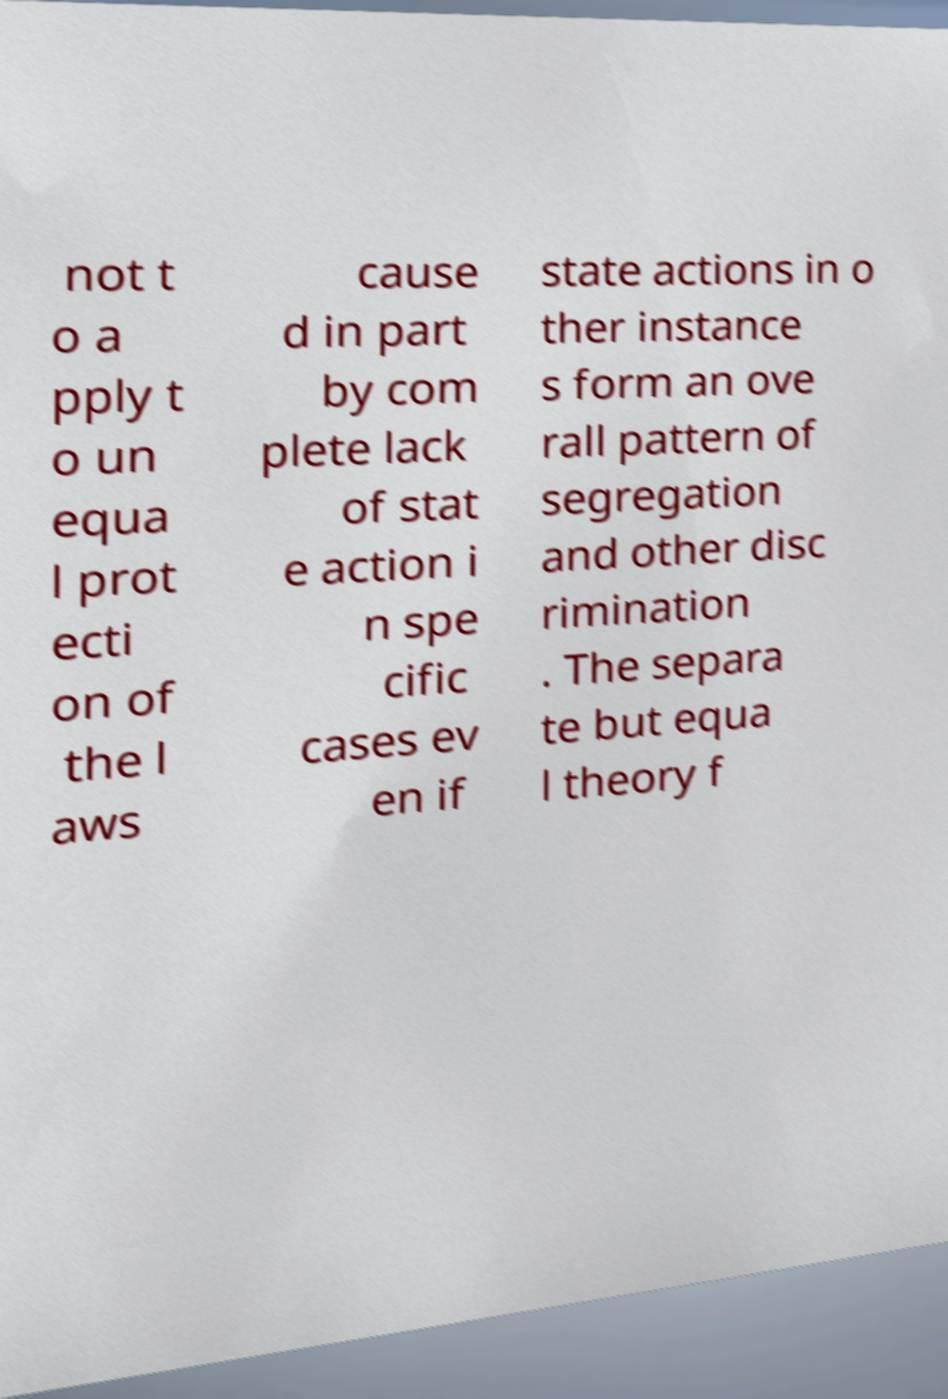For documentation purposes, I need the text within this image transcribed. Could you provide that? not t o a pply t o un equa l prot ecti on of the l aws cause d in part by com plete lack of stat e action i n spe cific cases ev en if state actions in o ther instance s form an ove rall pattern of segregation and other disc rimination . The separa te but equa l theory f 